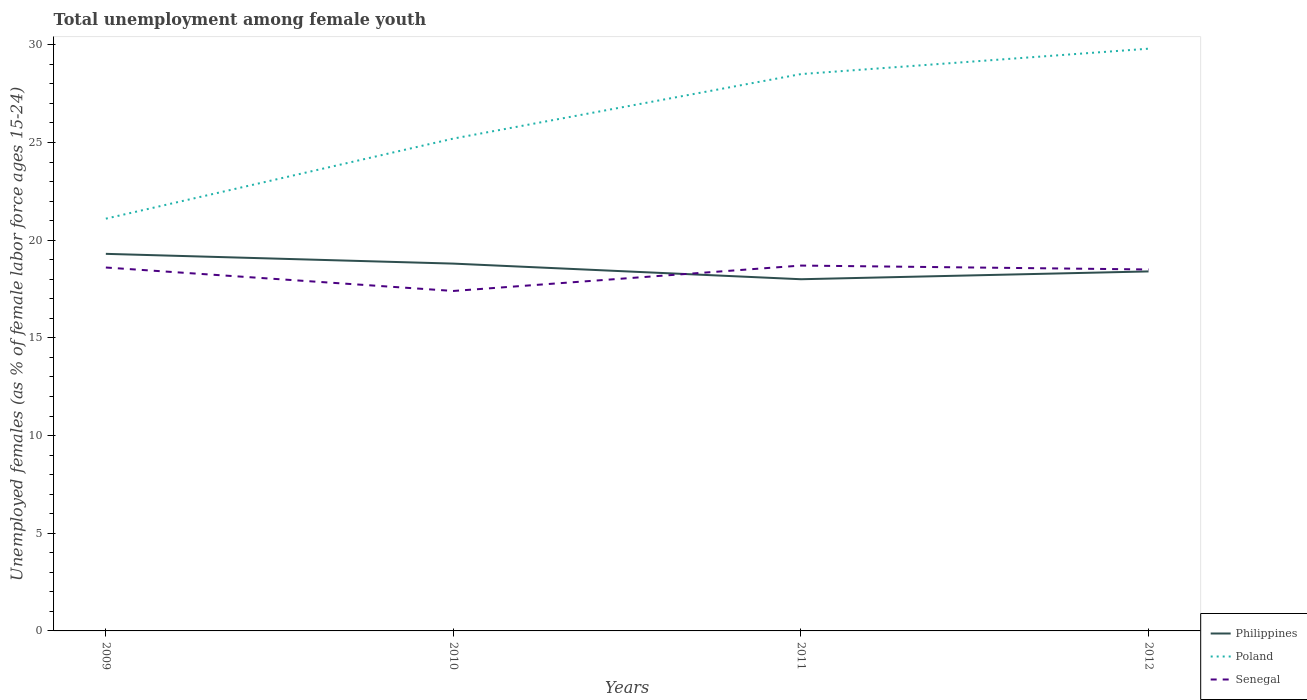Does the line corresponding to Poland intersect with the line corresponding to Senegal?
Ensure brevity in your answer.  No. Across all years, what is the maximum percentage of unemployed females in in Senegal?
Your answer should be compact. 17.4. What is the total percentage of unemployed females in in Philippines in the graph?
Give a very brief answer. 0.5. What is the difference between the highest and the second highest percentage of unemployed females in in Senegal?
Your answer should be very brief. 1.3. Is the percentage of unemployed females in in Poland strictly greater than the percentage of unemployed females in in Senegal over the years?
Offer a very short reply. No. How many lines are there?
Provide a short and direct response. 3. Where does the legend appear in the graph?
Provide a short and direct response. Bottom right. How are the legend labels stacked?
Keep it short and to the point. Vertical. What is the title of the graph?
Offer a terse response. Total unemployment among female youth. What is the label or title of the Y-axis?
Your answer should be compact. Unemployed females (as % of female labor force ages 15-24). What is the Unemployed females (as % of female labor force ages 15-24) of Philippines in 2009?
Offer a very short reply. 19.3. What is the Unemployed females (as % of female labor force ages 15-24) of Poland in 2009?
Provide a succinct answer. 21.1. What is the Unemployed females (as % of female labor force ages 15-24) of Senegal in 2009?
Your answer should be very brief. 18.6. What is the Unemployed females (as % of female labor force ages 15-24) in Philippines in 2010?
Provide a succinct answer. 18.8. What is the Unemployed females (as % of female labor force ages 15-24) in Poland in 2010?
Your answer should be very brief. 25.2. What is the Unemployed females (as % of female labor force ages 15-24) of Senegal in 2010?
Your answer should be compact. 17.4. What is the Unemployed females (as % of female labor force ages 15-24) of Poland in 2011?
Give a very brief answer. 28.5. What is the Unemployed females (as % of female labor force ages 15-24) of Senegal in 2011?
Your answer should be compact. 18.7. What is the Unemployed females (as % of female labor force ages 15-24) in Philippines in 2012?
Provide a short and direct response. 18.4. What is the Unemployed females (as % of female labor force ages 15-24) in Poland in 2012?
Make the answer very short. 29.8. Across all years, what is the maximum Unemployed females (as % of female labor force ages 15-24) in Philippines?
Offer a terse response. 19.3. Across all years, what is the maximum Unemployed females (as % of female labor force ages 15-24) of Poland?
Keep it short and to the point. 29.8. Across all years, what is the maximum Unemployed females (as % of female labor force ages 15-24) in Senegal?
Your response must be concise. 18.7. Across all years, what is the minimum Unemployed females (as % of female labor force ages 15-24) of Philippines?
Offer a very short reply. 18. Across all years, what is the minimum Unemployed females (as % of female labor force ages 15-24) of Poland?
Your response must be concise. 21.1. Across all years, what is the minimum Unemployed females (as % of female labor force ages 15-24) in Senegal?
Your answer should be compact. 17.4. What is the total Unemployed females (as % of female labor force ages 15-24) of Philippines in the graph?
Ensure brevity in your answer.  74.5. What is the total Unemployed females (as % of female labor force ages 15-24) of Poland in the graph?
Offer a terse response. 104.6. What is the total Unemployed females (as % of female labor force ages 15-24) of Senegal in the graph?
Offer a very short reply. 73.2. What is the difference between the Unemployed females (as % of female labor force ages 15-24) of Philippines in 2009 and that in 2010?
Provide a short and direct response. 0.5. What is the difference between the Unemployed females (as % of female labor force ages 15-24) of Poland in 2009 and that in 2010?
Your answer should be compact. -4.1. What is the difference between the Unemployed females (as % of female labor force ages 15-24) in Philippines in 2009 and that in 2011?
Provide a succinct answer. 1.3. What is the difference between the Unemployed females (as % of female labor force ages 15-24) in Philippines in 2009 and that in 2012?
Your answer should be very brief. 0.9. What is the difference between the Unemployed females (as % of female labor force ages 15-24) of Senegal in 2009 and that in 2012?
Offer a very short reply. 0.1. What is the difference between the Unemployed females (as % of female labor force ages 15-24) of Poland in 2010 and that in 2011?
Your answer should be compact. -3.3. What is the difference between the Unemployed females (as % of female labor force ages 15-24) of Philippines in 2010 and that in 2012?
Your response must be concise. 0.4. What is the difference between the Unemployed females (as % of female labor force ages 15-24) of Senegal in 2011 and that in 2012?
Keep it short and to the point. 0.2. What is the difference between the Unemployed females (as % of female labor force ages 15-24) in Philippines in 2009 and the Unemployed females (as % of female labor force ages 15-24) in Senegal in 2010?
Provide a short and direct response. 1.9. What is the difference between the Unemployed females (as % of female labor force ages 15-24) in Philippines in 2009 and the Unemployed females (as % of female labor force ages 15-24) in Senegal in 2011?
Offer a very short reply. 0.6. What is the difference between the Unemployed females (as % of female labor force ages 15-24) in Philippines in 2009 and the Unemployed females (as % of female labor force ages 15-24) in Poland in 2012?
Keep it short and to the point. -10.5. What is the difference between the Unemployed females (as % of female labor force ages 15-24) of Philippines in 2010 and the Unemployed females (as % of female labor force ages 15-24) of Poland in 2011?
Offer a terse response. -9.7. What is the difference between the Unemployed females (as % of female labor force ages 15-24) of Philippines in 2010 and the Unemployed females (as % of female labor force ages 15-24) of Poland in 2012?
Your response must be concise. -11. What is the difference between the Unemployed females (as % of female labor force ages 15-24) of Philippines in 2011 and the Unemployed females (as % of female labor force ages 15-24) of Poland in 2012?
Offer a very short reply. -11.8. What is the average Unemployed females (as % of female labor force ages 15-24) in Philippines per year?
Ensure brevity in your answer.  18.62. What is the average Unemployed females (as % of female labor force ages 15-24) of Poland per year?
Ensure brevity in your answer.  26.15. What is the average Unemployed females (as % of female labor force ages 15-24) in Senegal per year?
Your answer should be compact. 18.3. In the year 2009, what is the difference between the Unemployed females (as % of female labor force ages 15-24) in Philippines and Unemployed females (as % of female labor force ages 15-24) in Poland?
Your answer should be very brief. -1.8. In the year 2009, what is the difference between the Unemployed females (as % of female labor force ages 15-24) of Poland and Unemployed females (as % of female labor force ages 15-24) of Senegal?
Keep it short and to the point. 2.5. In the year 2010, what is the difference between the Unemployed females (as % of female labor force ages 15-24) in Philippines and Unemployed females (as % of female labor force ages 15-24) in Poland?
Keep it short and to the point. -6.4. In the year 2012, what is the difference between the Unemployed females (as % of female labor force ages 15-24) in Philippines and Unemployed females (as % of female labor force ages 15-24) in Senegal?
Offer a terse response. -0.1. In the year 2012, what is the difference between the Unemployed females (as % of female labor force ages 15-24) of Poland and Unemployed females (as % of female labor force ages 15-24) of Senegal?
Give a very brief answer. 11.3. What is the ratio of the Unemployed females (as % of female labor force ages 15-24) in Philippines in 2009 to that in 2010?
Your response must be concise. 1.03. What is the ratio of the Unemployed females (as % of female labor force ages 15-24) in Poland in 2009 to that in 2010?
Give a very brief answer. 0.84. What is the ratio of the Unemployed females (as % of female labor force ages 15-24) in Senegal in 2009 to that in 2010?
Ensure brevity in your answer.  1.07. What is the ratio of the Unemployed females (as % of female labor force ages 15-24) of Philippines in 2009 to that in 2011?
Offer a terse response. 1.07. What is the ratio of the Unemployed females (as % of female labor force ages 15-24) in Poland in 2009 to that in 2011?
Give a very brief answer. 0.74. What is the ratio of the Unemployed females (as % of female labor force ages 15-24) of Senegal in 2009 to that in 2011?
Your response must be concise. 0.99. What is the ratio of the Unemployed females (as % of female labor force ages 15-24) in Philippines in 2009 to that in 2012?
Make the answer very short. 1.05. What is the ratio of the Unemployed females (as % of female labor force ages 15-24) in Poland in 2009 to that in 2012?
Provide a short and direct response. 0.71. What is the ratio of the Unemployed females (as % of female labor force ages 15-24) in Senegal in 2009 to that in 2012?
Keep it short and to the point. 1.01. What is the ratio of the Unemployed females (as % of female labor force ages 15-24) in Philippines in 2010 to that in 2011?
Provide a succinct answer. 1.04. What is the ratio of the Unemployed females (as % of female labor force ages 15-24) in Poland in 2010 to that in 2011?
Provide a short and direct response. 0.88. What is the ratio of the Unemployed females (as % of female labor force ages 15-24) in Senegal in 2010 to that in 2011?
Offer a very short reply. 0.93. What is the ratio of the Unemployed females (as % of female labor force ages 15-24) in Philippines in 2010 to that in 2012?
Your response must be concise. 1.02. What is the ratio of the Unemployed females (as % of female labor force ages 15-24) of Poland in 2010 to that in 2012?
Provide a short and direct response. 0.85. What is the ratio of the Unemployed females (as % of female labor force ages 15-24) of Senegal in 2010 to that in 2012?
Your answer should be compact. 0.94. What is the ratio of the Unemployed females (as % of female labor force ages 15-24) in Philippines in 2011 to that in 2012?
Provide a short and direct response. 0.98. What is the ratio of the Unemployed females (as % of female labor force ages 15-24) in Poland in 2011 to that in 2012?
Make the answer very short. 0.96. What is the ratio of the Unemployed females (as % of female labor force ages 15-24) of Senegal in 2011 to that in 2012?
Keep it short and to the point. 1.01. What is the difference between the highest and the second highest Unemployed females (as % of female labor force ages 15-24) of Senegal?
Your answer should be compact. 0.1. What is the difference between the highest and the lowest Unemployed females (as % of female labor force ages 15-24) in Poland?
Ensure brevity in your answer.  8.7. 